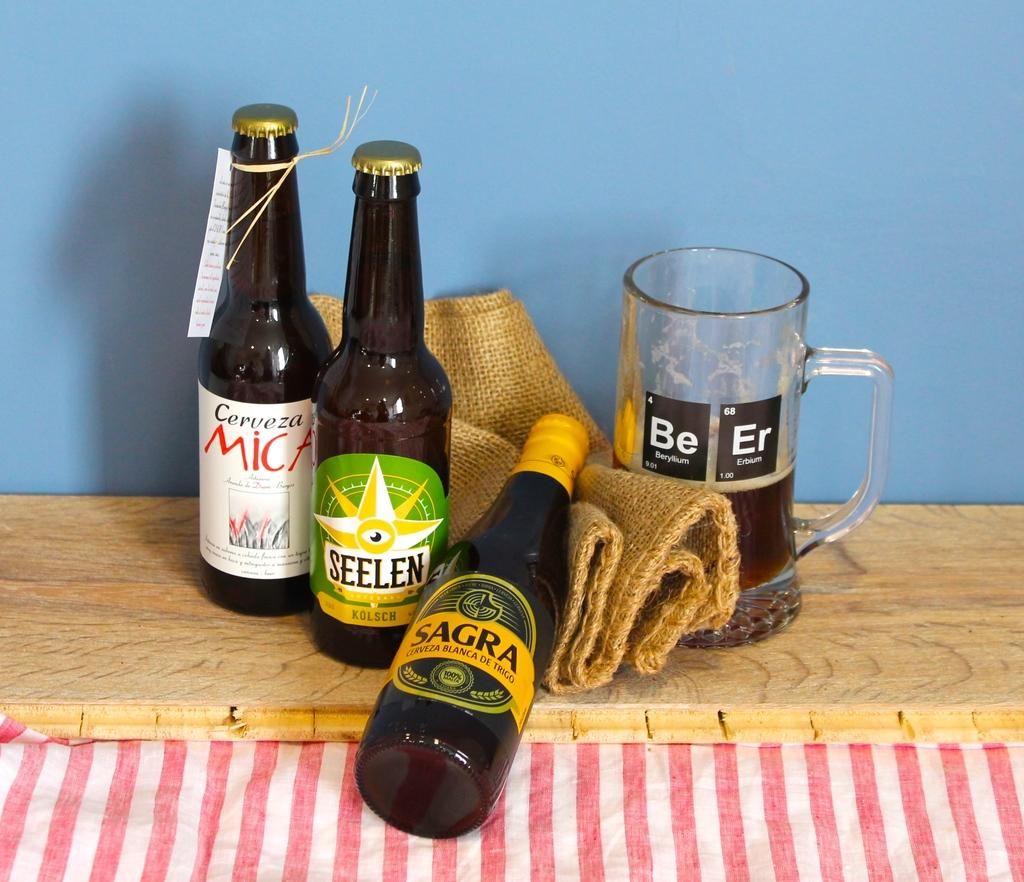<image>
Give a short and clear explanation of the subsequent image. Three bottles of alcohol next to a cup with the elements Beryllium and Erbium on it. 